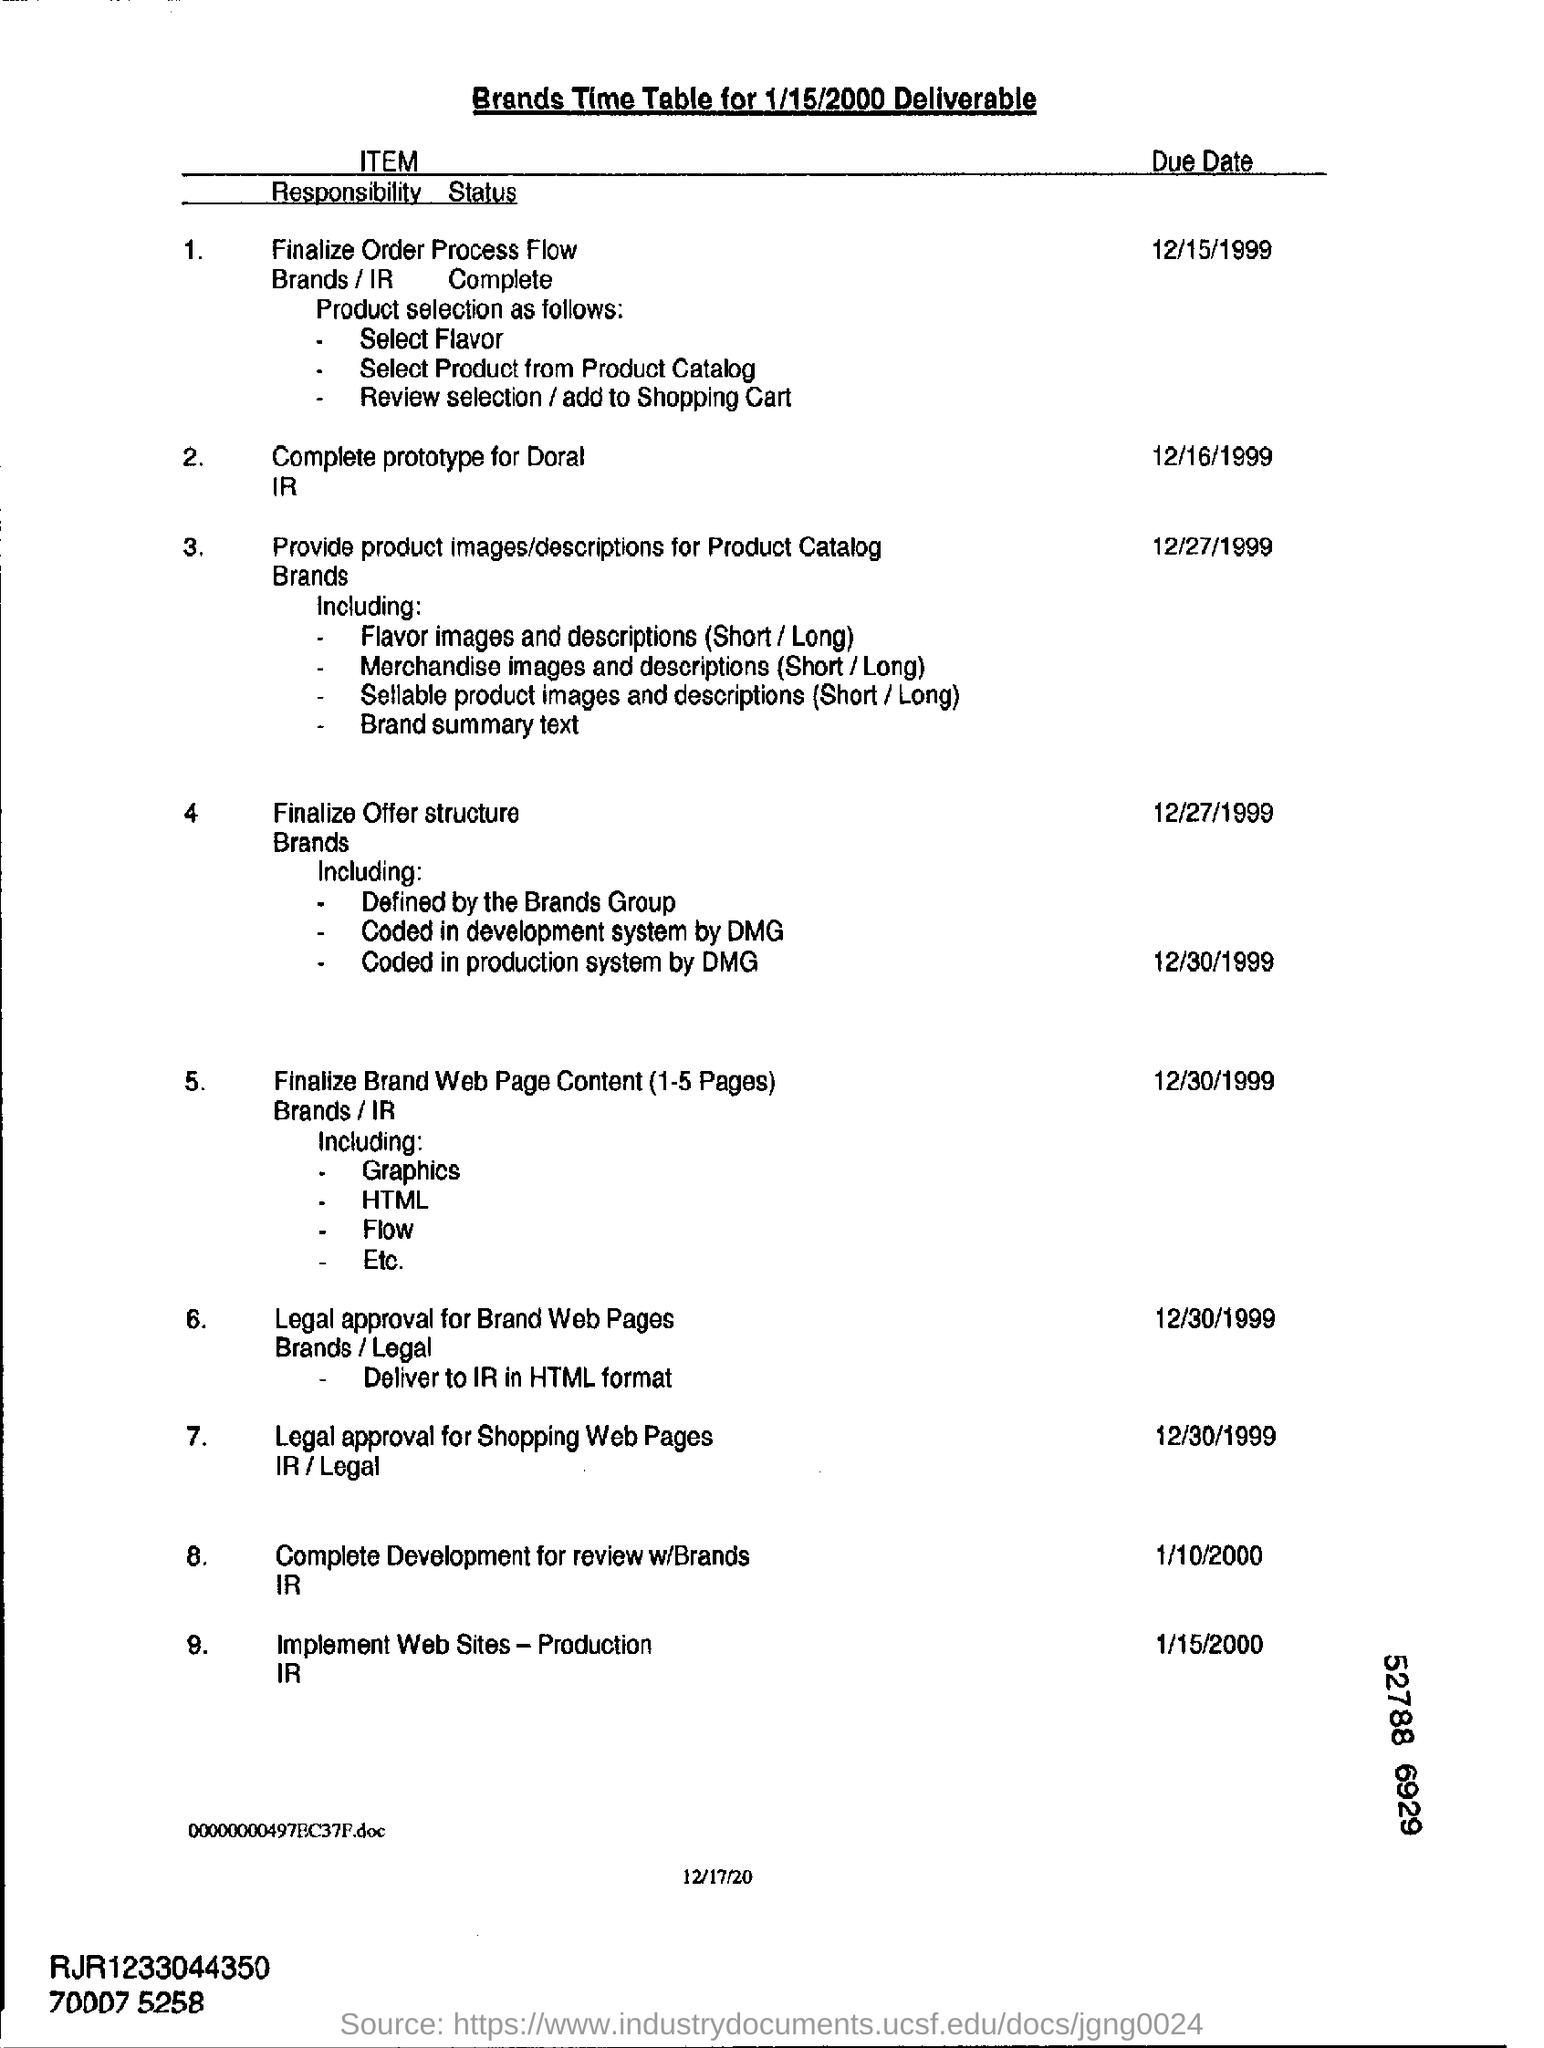Draw attention to some important aspects in this diagram. Please provide the date in the format "month/day/year" and the year only. The due date for the complete prototype for Doral IR is December 16, 1999. Please provide the due date for the implementation of the web site - production I/R. 